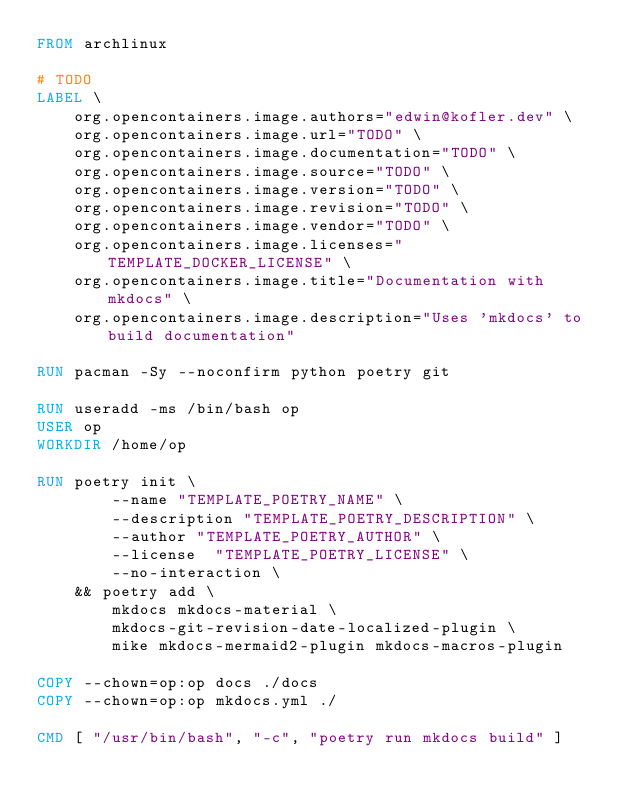<code> <loc_0><loc_0><loc_500><loc_500><_Dockerfile_>FROM archlinux

# TODO
LABEL \
	org.opencontainers.image.authors="edwin@kofler.dev" \
	org.opencontainers.image.url="TODO" \
	org.opencontainers.image.documentation="TODO" \
	org.opencontainers.image.source="TODO" \
	org.opencontainers.image.version="TODO" \
	org.opencontainers.image.revision="TODO" \
	org.opencontainers.image.vendor="TODO" \
	org.opencontainers.image.licenses="TEMPLATE_DOCKER_LICENSE" \
	org.opencontainers.image.title="Documentation with mkdocs" \
	org.opencontainers.image.description="Uses 'mkdocs' to build documentation"

RUN pacman -Sy --noconfirm python poetry git

RUN useradd -ms /bin/bash op
USER op
WORKDIR /home/op

RUN poetry init \
		--name "TEMPLATE_POETRY_NAME" \
		--description "TEMPLATE_POETRY_DESCRIPTION" \
		--author "TEMPLATE_POETRY_AUTHOR" \
		--license  "TEMPLATE_POETRY_LICENSE" \
		--no-interaction \
	&& poetry add \
		mkdocs mkdocs-material \
		mkdocs-git-revision-date-localized-plugin \
		mike mkdocs-mermaid2-plugin mkdocs-macros-plugin

COPY --chown=op:op docs ./docs
COPY --chown=op:op mkdocs.yml ./

CMD [ "/usr/bin/bash", "-c", "poetry run mkdocs build" ]
</code> 